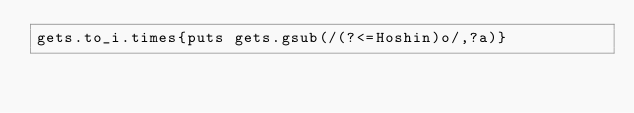Convert code to text. <code><loc_0><loc_0><loc_500><loc_500><_Ruby_>gets.to_i.times{puts gets.gsub(/(?<=Hoshin)o/,?a)}</code> 